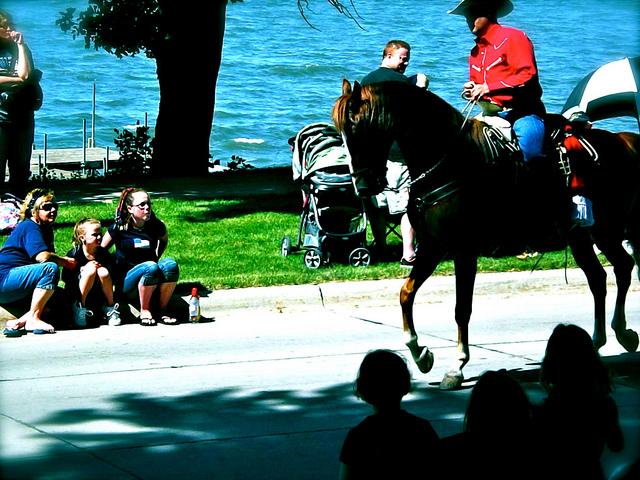What is the man in the red shirt riding?
Short answer required. Horse. Is there a baby stroller in the picture?
Write a very short answer. Yes. What are the people watching?
Write a very short answer. Parade. 